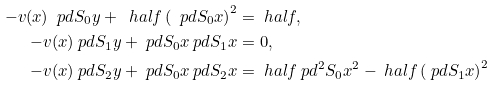Convert formula to latex. <formula><loc_0><loc_0><loc_500><loc_500>- v ( x ) \ p d { S _ { 0 } } { y } + \ h a l f \left ( \ p d { S _ { 0 } } { x } \right ) ^ { 2 } & = \ h a l f , \\ - v ( x ) \ p d { S _ { 1 } } { y } + \ p d { S _ { 0 } } { x } \ p d { S _ { 1 } } { x } & = 0 , \\ - v ( x ) \ p d { S _ { 2 } } { y } + \ p d { S _ { 0 } } { x } \ p d { S _ { 2 } } { x } & = \ h a l f \ p d { ^ { 2 } S _ { 0 } } { x ^ { 2 } } - \ h a l f \left ( \ p d { S _ { 1 } } { x } \right ) ^ { 2 }</formula> 